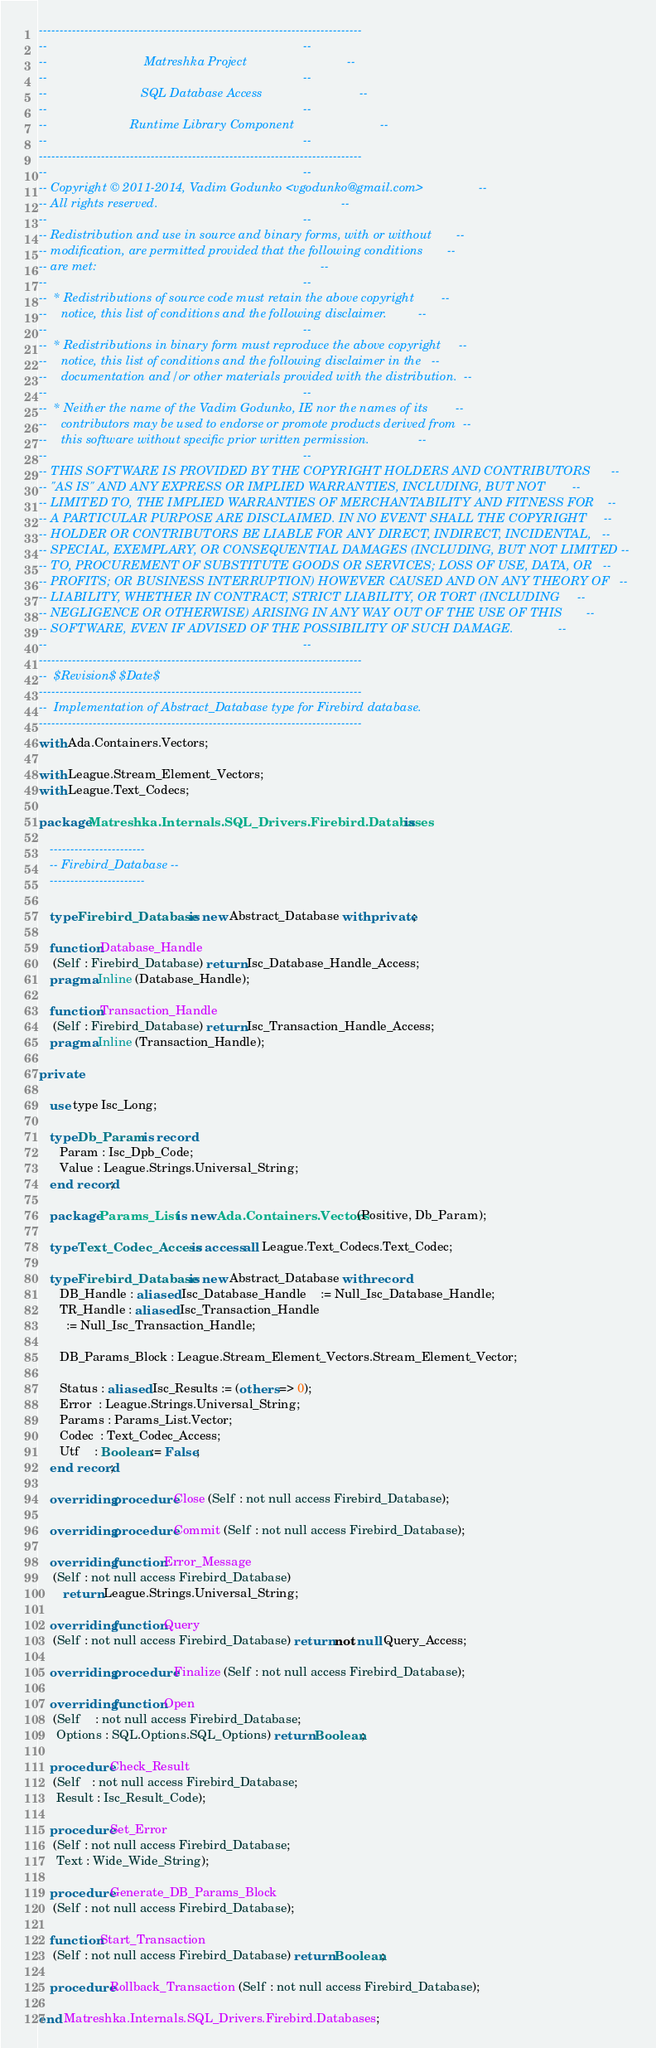<code> <loc_0><loc_0><loc_500><loc_500><_Ada_>------------------------------------------------------------------------------
--                                                                          --
--                            Matreshka Project                             --
--                                                                          --
--                           SQL Database Access                            --
--                                                                          --
--                        Runtime Library Component                         --
--                                                                          --
------------------------------------------------------------------------------
--                                                                          --
-- Copyright © 2011-2014, Vadim Godunko <vgodunko@gmail.com>                --
-- All rights reserved.                                                     --
--                                                                          --
-- Redistribution and use in source and binary forms, with or without       --
-- modification, are permitted provided that the following conditions       --
-- are met:                                                                 --
--                                                                          --
--  * Redistributions of source code must retain the above copyright        --
--    notice, this list of conditions and the following disclaimer.         --
--                                                                          --
--  * Redistributions in binary form must reproduce the above copyright     --
--    notice, this list of conditions and the following disclaimer in the   --
--    documentation and/or other materials provided with the distribution.  --
--                                                                          --
--  * Neither the name of the Vadim Godunko, IE nor the names of its        --
--    contributors may be used to endorse or promote products derived from  --
--    this software without specific prior written permission.              --
--                                                                          --
-- THIS SOFTWARE IS PROVIDED BY THE COPYRIGHT HOLDERS AND CONTRIBUTORS      --
-- "AS IS" AND ANY EXPRESS OR IMPLIED WARRANTIES, INCLUDING, BUT NOT        --
-- LIMITED TO, THE IMPLIED WARRANTIES OF MERCHANTABILITY AND FITNESS FOR    --
-- A PARTICULAR PURPOSE ARE DISCLAIMED. IN NO EVENT SHALL THE COPYRIGHT     --
-- HOLDER OR CONTRIBUTORS BE LIABLE FOR ANY DIRECT, INDIRECT, INCIDENTAL,   --
-- SPECIAL, EXEMPLARY, OR CONSEQUENTIAL DAMAGES (INCLUDING, BUT NOT LIMITED --
-- TO, PROCUREMENT OF SUBSTITUTE GOODS OR SERVICES; LOSS OF USE, DATA, OR   --
-- PROFITS; OR BUSINESS INTERRUPTION) HOWEVER CAUSED AND ON ANY THEORY OF   --
-- LIABILITY, WHETHER IN CONTRACT, STRICT LIABILITY, OR TORT (INCLUDING     --
-- NEGLIGENCE OR OTHERWISE) ARISING IN ANY WAY OUT OF THE USE OF THIS       --
-- SOFTWARE, EVEN IF ADVISED OF THE POSSIBILITY OF SUCH DAMAGE.             --
--                                                                          --
------------------------------------------------------------------------------
--  $Revision$ $Date$
------------------------------------------------------------------------------
--  Implementation of Abstract_Database type for Firebird database.
------------------------------------------------------------------------------
with Ada.Containers.Vectors;

with League.Stream_Element_Vectors;
with League.Text_Codecs;

package Matreshka.Internals.SQL_Drivers.Firebird.Databases is

   -----------------------
   -- Firebird_Database --
   -----------------------

   type Firebird_Database is new Abstract_Database with private;

   function Database_Handle
    (Self : Firebird_Database) return Isc_Database_Handle_Access;
   pragma Inline (Database_Handle);

   function Transaction_Handle
    (Self : Firebird_Database) return Isc_Transaction_Handle_Access;
   pragma Inline (Transaction_Handle);

private

   use type Isc_Long;

   type Db_Param is record
      Param : Isc_Dpb_Code;
      Value : League.Strings.Universal_String;
   end record;

   package Params_List is new Ada.Containers.Vectors (Positive, Db_Param);

   type Text_Codec_Access is access all League.Text_Codecs.Text_Codec;

   type Firebird_Database is new Abstract_Database with record
      DB_Handle : aliased Isc_Database_Handle    := Null_Isc_Database_Handle;
      TR_Handle : aliased Isc_Transaction_Handle
        := Null_Isc_Transaction_Handle;

      DB_Params_Block : League.Stream_Element_Vectors.Stream_Element_Vector;

      Status : aliased Isc_Results := (others => 0);
      Error  : League.Strings.Universal_String;
      Params : Params_List.Vector;
      Codec  : Text_Codec_Access;
      Utf    : Boolean := False;
   end record;

   overriding procedure Close (Self : not null access Firebird_Database);

   overriding procedure Commit (Self : not null access Firebird_Database);

   overriding function Error_Message
    (Self : not null access Firebird_Database)
       return League.Strings.Universal_String;

   overriding function Query
    (Self : not null access Firebird_Database) return not null Query_Access;

   overriding procedure Finalize (Self : not null access Firebird_Database);

   overriding function Open
    (Self    : not null access Firebird_Database;
     Options : SQL.Options.SQL_Options) return Boolean;

   procedure Check_Result
    (Self   : not null access Firebird_Database;
     Result : Isc_Result_Code);

   procedure Set_Error
    (Self : not null access Firebird_Database;
     Text : Wide_Wide_String);

   procedure Generate_DB_Params_Block
    (Self : not null access Firebird_Database);

   function Start_Transaction
    (Self : not null access Firebird_Database) return Boolean;

   procedure Rollback_Transaction (Self : not null access Firebird_Database);

end Matreshka.Internals.SQL_Drivers.Firebird.Databases;
</code> 